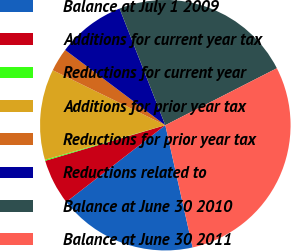Convert chart to OTSL. <chart><loc_0><loc_0><loc_500><loc_500><pie_chart><fcel>Balance at July 1 2009<fcel>Additions for current year tax<fcel>Reductions for current year<fcel>Additions for prior year tax<fcel>Reductions for prior year tax<fcel>Reductions related to<fcel>Balance at June 30 2010<fcel>Balance at June 30 2011<nl><fcel>18.0%<fcel>5.91%<fcel>0.13%<fcel>11.69%<fcel>3.02%<fcel>8.8%<fcel>23.44%<fcel>29.02%<nl></chart> 